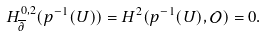<formula> <loc_0><loc_0><loc_500><loc_500>H ^ { 0 , 2 } _ { \overline { \partial } } ( p ^ { - 1 } ( U ) ) = H ^ { 2 } ( p ^ { - 1 } ( U ) , \mathcal { O } ) = 0 .</formula> 